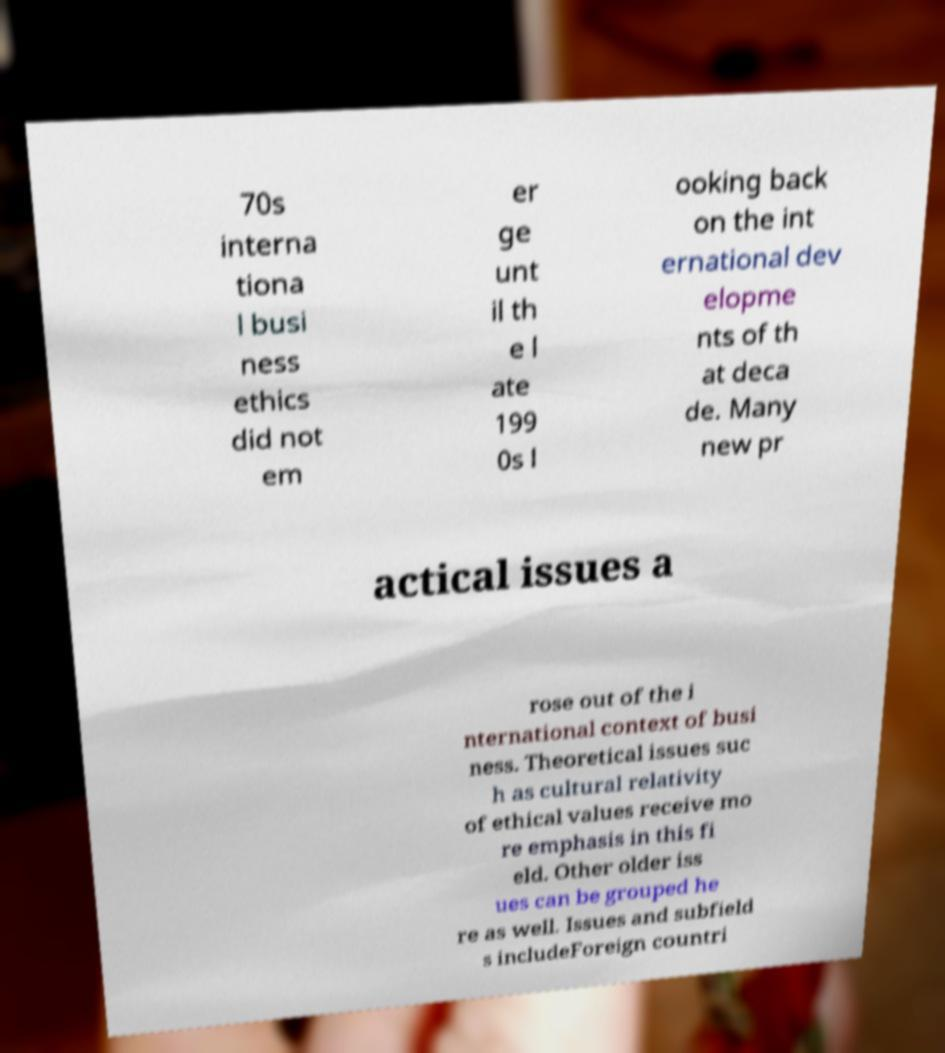Could you extract and type out the text from this image? 70s interna tiona l busi ness ethics did not em er ge unt il th e l ate 199 0s l ooking back on the int ernational dev elopme nts of th at deca de. Many new pr actical issues a rose out of the i nternational context of busi ness. Theoretical issues suc h as cultural relativity of ethical values receive mo re emphasis in this fi eld. Other older iss ues can be grouped he re as well. Issues and subfield s includeForeign countri 